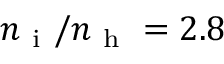<formula> <loc_0><loc_0><loc_500><loc_500>n _ { i } / n _ { h } = 2 . 8</formula> 